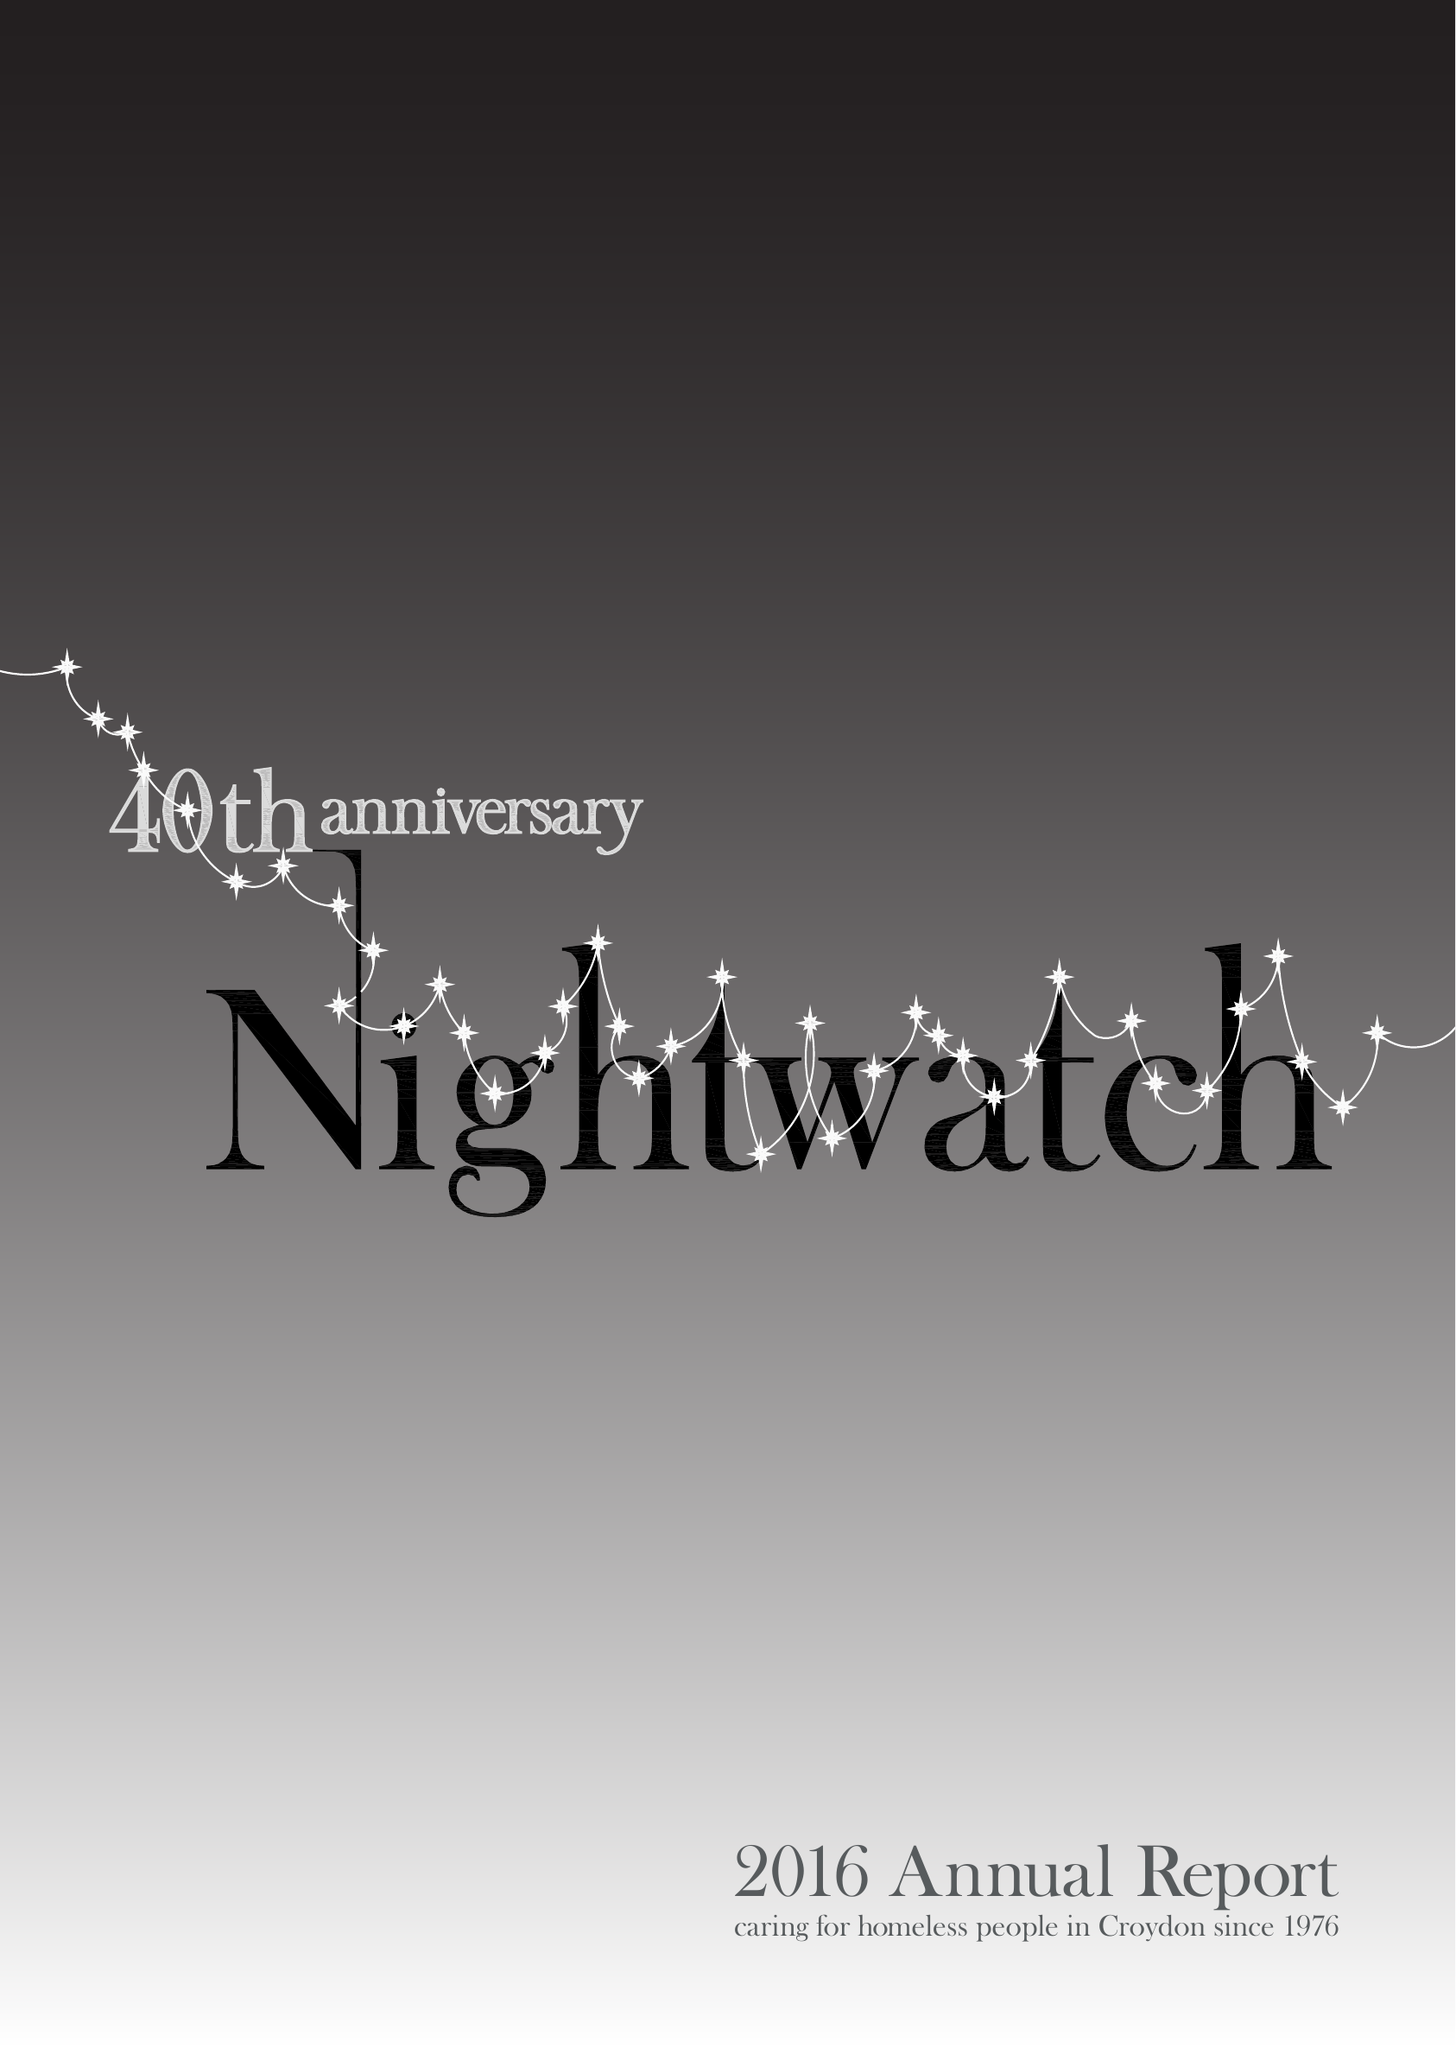What is the value for the address__street_line?
Answer the question using a single word or phrase. PO BOX 9576 